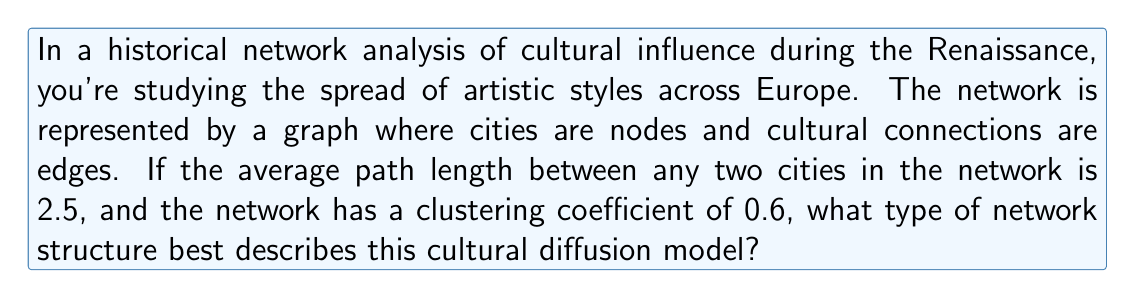Solve this math problem. To determine the type of network structure that best describes this cultural diffusion model, we need to analyze the given metrics:

1. Average path length: 2.5
2. Clustering coefficient: 0.6

Let's consider the characteristics of different network types:

1. Random networks:
   - Low average path length
   - Low clustering coefficient

2. Regular lattice networks:
   - High average path length
   - High clustering coefficient

3. Small-world networks:
   - Low average path length
   - High clustering coefficient

The given network has:
- A relatively low average path length (2.5), which indicates that information or cultural influences can spread quickly across the network.
- A high clustering coefficient (0.6), suggesting that nodes tend to form tightly knit groups.

These characteristics are consistent with a small-world network, which was first described by Watts and Strogatz (1998). Small-world networks are characterized by:

$$L \approx L_{random}$$
$$C \gg C_{random}$$

Where $L$ is the average path length, and $C$ is the clustering coefficient.

Small-world networks are particularly relevant for modeling cultural diffusion because they capture both:
1. The tendency for local clustering (represented by the high clustering coefficient), which reflects strong regional cultural ties.
2. The presence of occasional long-range connections (represented by the low average path length), which allows for the rapid spread of ideas across distant parts of the network.

This network structure would explain how Renaissance artistic styles could maintain strong regional characteristics while also spreading relatively quickly across Europe through key connections between cultural centers.
Answer: Small-world network 